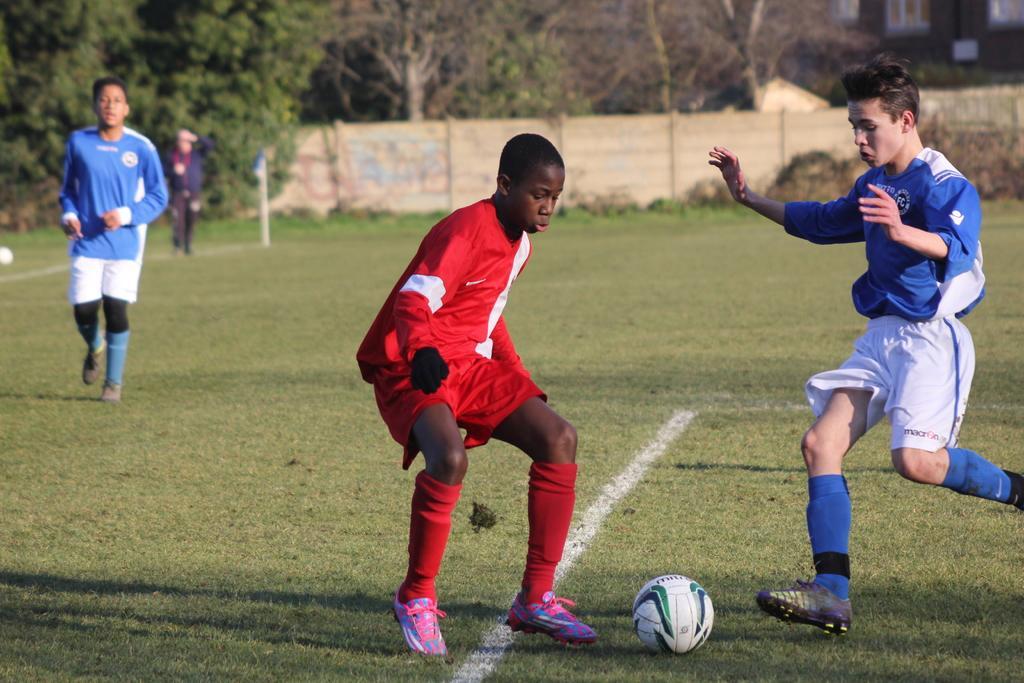Could you give a brief overview of what you see in this image? Here a boy is playing the football, he wore a red color dress. In the right side a boy is running, he wore a blue color t-shirt and in the long back side there is a wall, in the left side there are trees. 